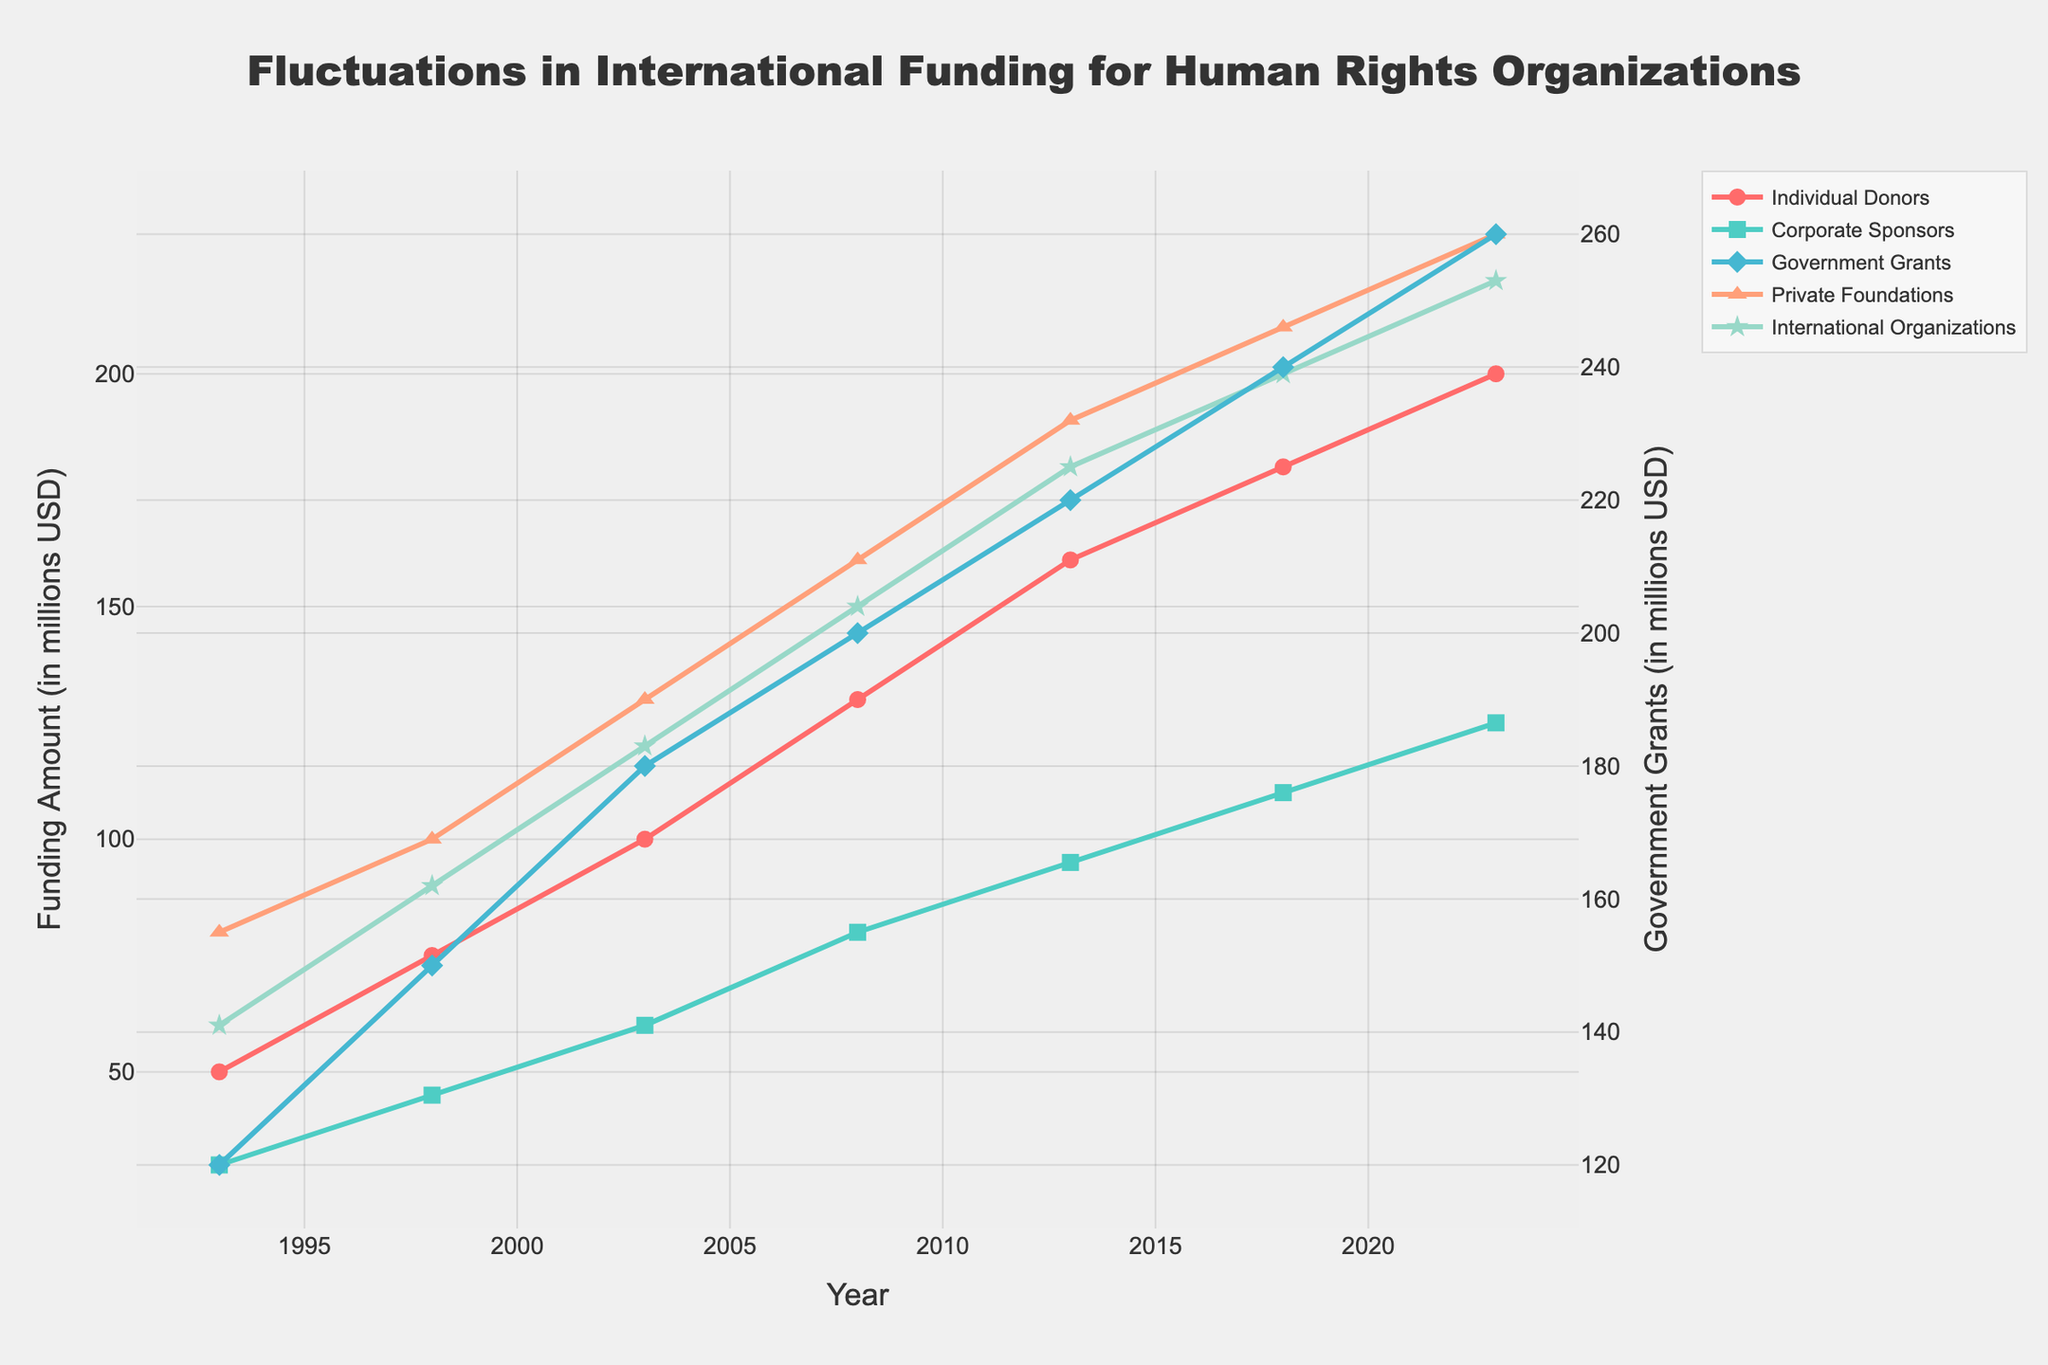What year did International Organizations provide funding of 120 million USD? Locate the line for International Organizations and find the point where it reaches 120 million USD on the y-axis. This occurs in the year 2003.
Answer: 2003 Which donor type had the highest increase in funding from 1993 to 2023? Calculate the difference in funding between 2023 and 1993 for each donor type. Government Grants increased by 140 million, which is the highest increase compared to other types.
Answer: Government Grants How much total funding did Individual Donors and Corporate Sponsors provide in 2008? Individual Donors provided 130 million USD and Corporate Sponsors provided 80 million USD in 2008. Adding these amounts gives 130 + 80 = 210 million USD.
Answer: 210 In what year did Private Foundations surpass 100 million USD in funding? Follow the line for Private Foundations to see when it crosses 100 million USD on the y-axis. This occurs around 2003.
Answer: 2003 Which two donor types had the same funding amount in 1998? Compare the values for all donor types in 1998. Both Corporate Sponsors and Private Foundations had funding amounts of 45 million USD and 100 million USD respectively. Look closely, no two donor types had the same funding amount.
Answer: None In 2013, did Government Grants exceed the combined funding of Corporate Sponsors and Private Foundations? In 2013, Government Grants amounted to 220 million USD, while Corporate Sponsors and Private Foundations together amounted to 95 + 190 = 285 million USD. Government Grants did not exceed their combined funding.
Answer: No What was the average annual funding increase for Individual Donors over the 30 years? Calculate the total increase from 1993 to 2023, then divide by the number of intervals (30 years divided into 6 intervals). Increase is 200 - 50 = 150 million USD. The average increase per 5 years is 150/6, which simplifies to 25 million USD every 5 years.
Answer: 25 million USD per 5 years 